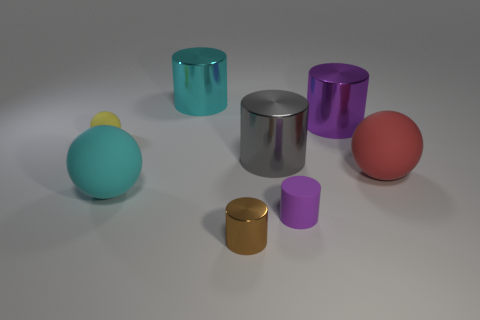There is a cylinder on the left side of the brown cylinder; what material is it?
Your answer should be very brief. Metal. What number of things are gray metal things or metallic cylinders that are right of the tiny metallic cylinder?
Your answer should be compact. 2. What shape is the matte object that is the same size as the red matte sphere?
Your response must be concise. Sphere. What number of tiny matte cylinders have the same color as the tiny metal cylinder?
Provide a succinct answer. 0. Are the cyan object that is behind the big red ball and the brown cylinder made of the same material?
Make the answer very short. Yes. The large cyan shiny thing is what shape?
Your answer should be compact. Cylinder. What number of brown objects are large rubber things or shiny things?
Your answer should be compact. 1. How many other things are the same material as the small purple object?
Keep it short and to the point. 3. Does the small object behind the cyan sphere have the same shape as the big cyan metallic object?
Make the answer very short. No. Is there a small yellow metal object?
Offer a terse response. No. 